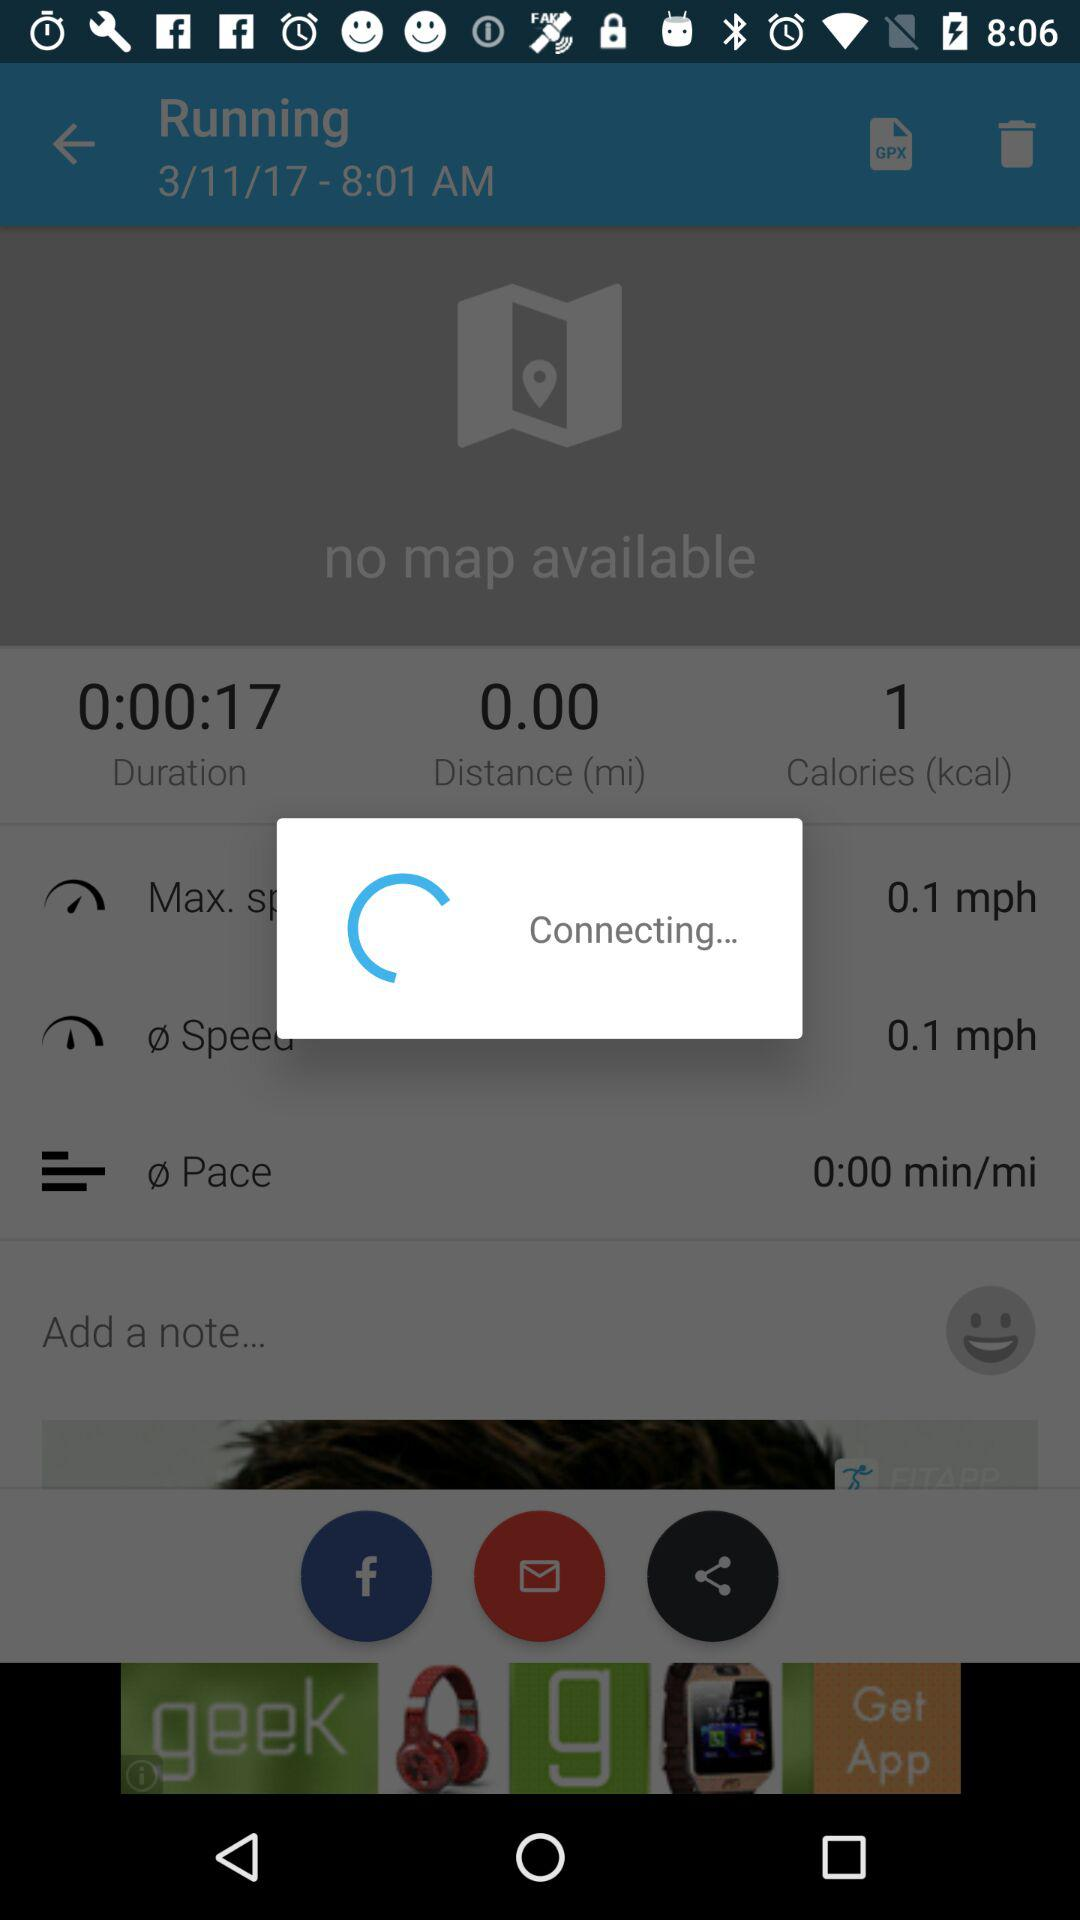What is the count of calories? The count of calories is 1. 